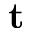Convert formula to latex. <formula><loc_0><loc_0><loc_500><loc_500>t</formula> 